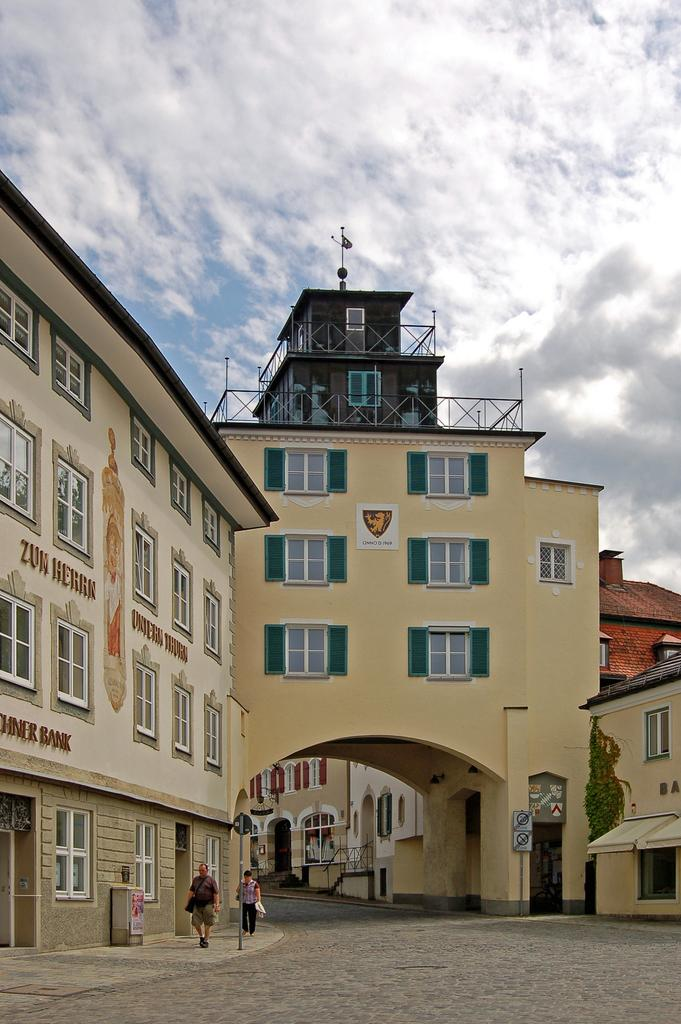What are the two persons in the image doing? The two persons in the image are walking on the left side of the image. Where are they walking? They are walking on a footpath. What can be seen in the middle of the image? There are buildings in the middle of the image. What is the condition of the sky in the image? The sky is cloudy and visible at the top of the image. What type of birthday celebration is happening in the image? There is no indication of a birthday celebration in the image. How does the garden look in the image? There is no garden present in the image. 